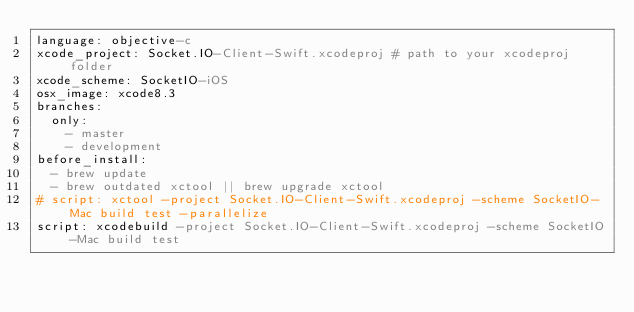<code> <loc_0><loc_0><loc_500><loc_500><_YAML_>language: objective-c
xcode_project: Socket.IO-Client-Swift.xcodeproj # path to your xcodeproj folder
xcode_scheme: SocketIO-iOS
osx_image: xcode8.3
branches:
  only:
    - master
    - development
before_install:
  - brew update
  - brew outdated xctool || brew upgrade xctool
# script: xctool -project Socket.IO-Client-Swift.xcodeproj -scheme SocketIO-Mac build test -parallelize
script: xcodebuild -project Socket.IO-Client-Swift.xcodeproj -scheme SocketIO-Mac build test
</code> 